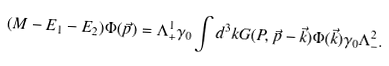Convert formula to latex. <formula><loc_0><loc_0><loc_500><loc_500>( M - E _ { 1 } - E _ { 2 } ) \Phi ( \vec { p } ) = \Lambda ^ { 1 } _ { + } \gamma _ { 0 } \int d ^ { 3 } k G ( P , \vec { p } - \vec { k } ) \Phi ( \vec { k } ) \gamma _ { 0 } \Lambda ^ { 2 } _ { - } .</formula> 